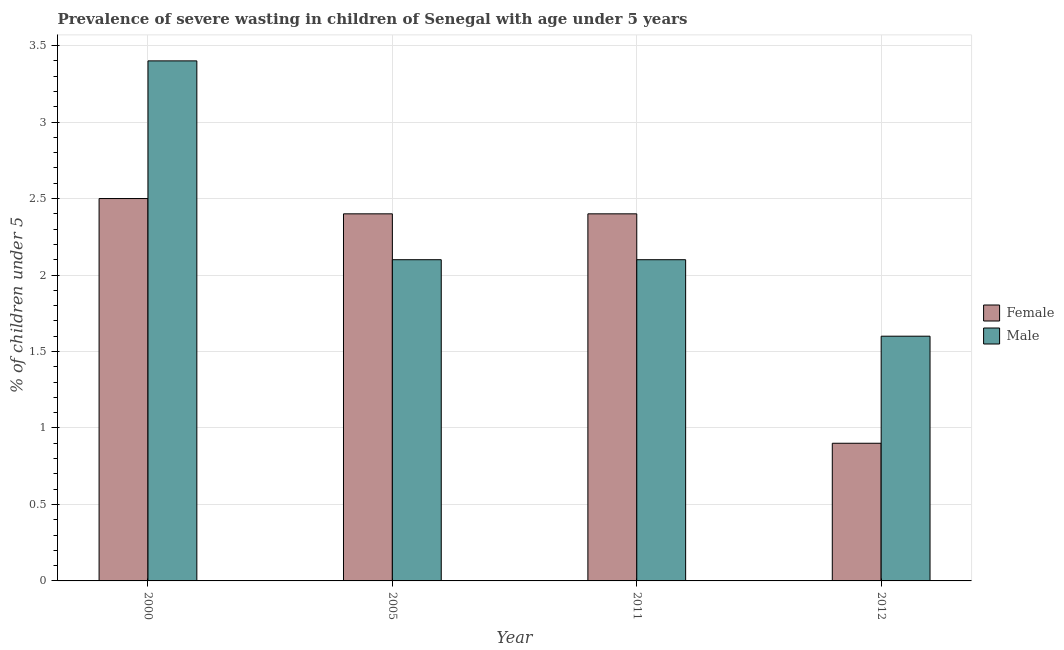Are the number of bars per tick equal to the number of legend labels?
Keep it short and to the point. Yes. In how many cases, is the number of bars for a given year not equal to the number of legend labels?
Your response must be concise. 0. What is the percentage of undernourished female children in 2005?
Your response must be concise. 2.4. Across all years, what is the minimum percentage of undernourished female children?
Your response must be concise. 0.9. In which year was the percentage of undernourished male children maximum?
Keep it short and to the point. 2000. What is the total percentage of undernourished female children in the graph?
Provide a succinct answer. 8.2. What is the difference between the percentage of undernourished female children in 2005 and that in 2012?
Ensure brevity in your answer.  1.5. What is the difference between the percentage of undernourished male children in 2012 and the percentage of undernourished female children in 2000?
Keep it short and to the point. -1.8. What is the average percentage of undernourished male children per year?
Make the answer very short. 2.3. In the year 2000, what is the difference between the percentage of undernourished male children and percentage of undernourished female children?
Your response must be concise. 0. What is the ratio of the percentage of undernourished female children in 2005 to that in 2012?
Your answer should be compact. 2.67. Is the difference between the percentage of undernourished female children in 2000 and 2012 greater than the difference between the percentage of undernourished male children in 2000 and 2012?
Offer a very short reply. No. What is the difference between the highest and the second highest percentage of undernourished female children?
Ensure brevity in your answer.  0.1. What is the difference between the highest and the lowest percentage of undernourished male children?
Your answer should be compact. 1.8. What does the 2nd bar from the left in 2012 represents?
Give a very brief answer. Male. How many years are there in the graph?
Offer a terse response. 4. Are the values on the major ticks of Y-axis written in scientific E-notation?
Ensure brevity in your answer.  No. Does the graph contain any zero values?
Make the answer very short. No. How many legend labels are there?
Offer a terse response. 2. How are the legend labels stacked?
Keep it short and to the point. Vertical. What is the title of the graph?
Your response must be concise. Prevalence of severe wasting in children of Senegal with age under 5 years. What is the label or title of the X-axis?
Keep it short and to the point. Year. What is the label or title of the Y-axis?
Give a very brief answer.  % of children under 5. What is the  % of children under 5 in Male in 2000?
Offer a terse response. 3.4. What is the  % of children under 5 in Female in 2005?
Your answer should be compact. 2.4. What is the  % of children under 5 of Male in 2005?
Offer a very short reply. 2.1. What is the  % of children under 5 in Female in 2011?
Ensure brevity in your answer.  2.4. What is the  % of children under 5 in Male in 2011?
Offer a terse response. 2.1. What is the  % of children under 5 in Female in 2012?
Offer a very short reply. 0.9. What is the  % of children under 5 of Male in 2012?
Provide a succinct answer. 1.6. Across all years, what is the maximum  % of children under 5 in Female?
Provide a short and direct response. 2.5. Across all years, what is the maximum  % of children under 5 of Male?
Ensure brevity in your answer.  3.4. Across all years, what is the minimum  % of children under 5 in Female?
Offer a terse response. 0.9. Across all years, what is the minimum  % of children under 5 in Male?
Ensure brevity in your answer.  1.6. What is the difference between the  % of children under 5 of Female in 2000 and that in 2005?
Your answer should be very brief. 0.1. What is the difference between the  % of children under 5 in Male in 2000 and that in 2005?
Provide a short and direct response. 1.3. What is the difference between the  % of children under 5 in Female in 2000 and that in 2012?
Your answer should be very brief. 1.6. What is the difference between the  % of children under 5 of Male in 2000 and that in 2012?
Keep it short and to the point. 1.8. What is the difference between the  % of children under 5 of Female in 2005 and that in 2011?
Offer a terse response. 0. What is the difference between the  % of children under 5 in Male in 2005 and that in 2011?
Your answer should be very brief. 0. What is the difference between the  % of children under 5 of Male in 2011 and that in 2012?
Ensure brevity in your answer.  0.5. What is the difference between the  % of children under 5 of Female in 2000 and the  % of children under 5 of Male in 2012?
Your answer should be very brief. 0.9. What is the difference between the  % of children under 5 of Female in 2005 and the  % of children under 5 of Male in 2012?
Your answer should be very brief. 0.8. What is the average  % of children under 5 in Female per year?
Make the answer very short. 2.05. In the year 2000, what is the difference between the  % of children under 5 in Female and  % of children under 5 in Male?
Your answer should be compact. -0.9. In the year 2012, what is the difference between the  % of children under 5 in Female and  % of children under 5 in Male?
Provide a short and direct response. -0.7. What is the ratio of the  % of children under 5 in Female in 2000 to that in 2005?
Provide a short and direct response. 1.04. What is the ratio of the  % of children under 5 in Male in 2000 to that in 2005?
Offer a very short reply. 1.62. What is the ratio of the  % of children under 5 in Female in 2000 to that in 2011?
Your answer should be very brief. 1.04. What is the ratio of the  % of children under 5 of Male in 2000 to that in 2011?
Offer a terse response. 1.62. What is the ratio of the  % of children under 5 in Female in 2000 to that in 2012?
Offer a very short reply. 2.78. What is the ratio of the  % of children under 5 of Male in 2000 to that in 2012?
Offer a very short reply. 2.12. What is the ratio of the  % of children under 5 in Female in 2005 to that in 2011?
Provide a short and direct response. 1. What is the ratio of the  % of children under 5 of Male in 2005 to that in 2011?
Provide a short and direct response. 1. What is the ratio of the  % of children under 5 of Female in 2005 to that in 2012?
Offer a very short reply. 2.67. What is the ratio of the  % of children under 5 in Male in 2005 to that in 2012?
Provide a short and direct response. 1.31. What is the ratio of the  % of children under 5 of Female in 2011 to that in 2012?
Your answer should be compact. 2.67. What is the ratio of the  % of children under 5 in Male in 2011 to that in 2012?
Keep it short and to the point. 1.31. What is the difference between the highest and the second highest  % of children under 5 in Female?
Provide a short and direct response. 0.1. 